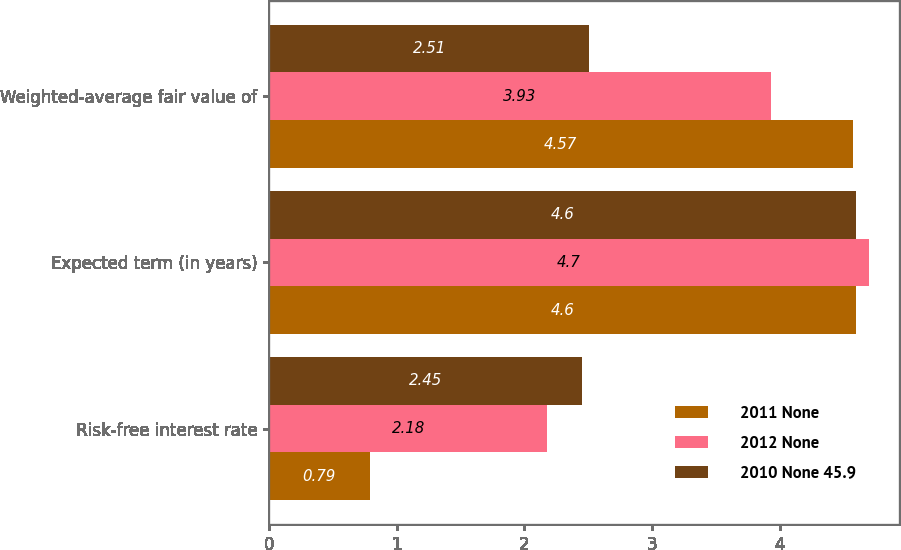<chart> <loc_0><loc_0><loc_500><loc_500><stacked_bar_chart><ecel><fcel>Risk-free interest rate<fcel>Expected term (in years)<fcel>Weighted-average fair value of<nl><fcel>2011 None<fcel>0.79<fcel>4.6<fcel>4.57<nl><fcel>2012 None<fcel>2.18<fcel>4.7<fcel>3.93<nl><fcel>2010 None 45.9<fcel>2.45<fcel>4.6<fcel>2.51<nl></chart> 